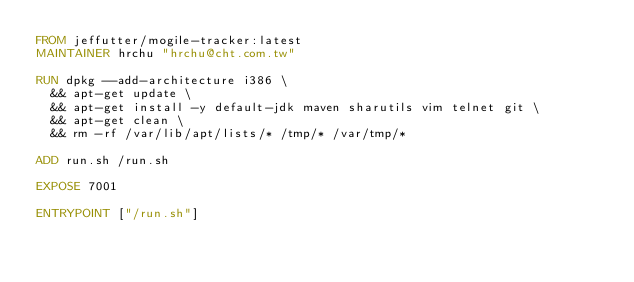Convert code to text. <code><loc_0><loc_0><loc_500><loc_500><_Dockerfile_>FROM jeffutter/mogile-tracker:latest
MAINTAINER hrchu "hrchu@cht.com.tw"

RUN dpkg --add-architecture i386 \
  && apt-get update \
  && apt-get install -y default-jdk maven sharutils vim telnet git \
  && apt-get clean \
  && rm -rf /var/lib/apt/lists/* /tmp/* /var/tmp/*

ADD run.sh /run.sh

EXPOSE 7001

ENTRYPOINT ["/run.sh"]

 
 
</code> 